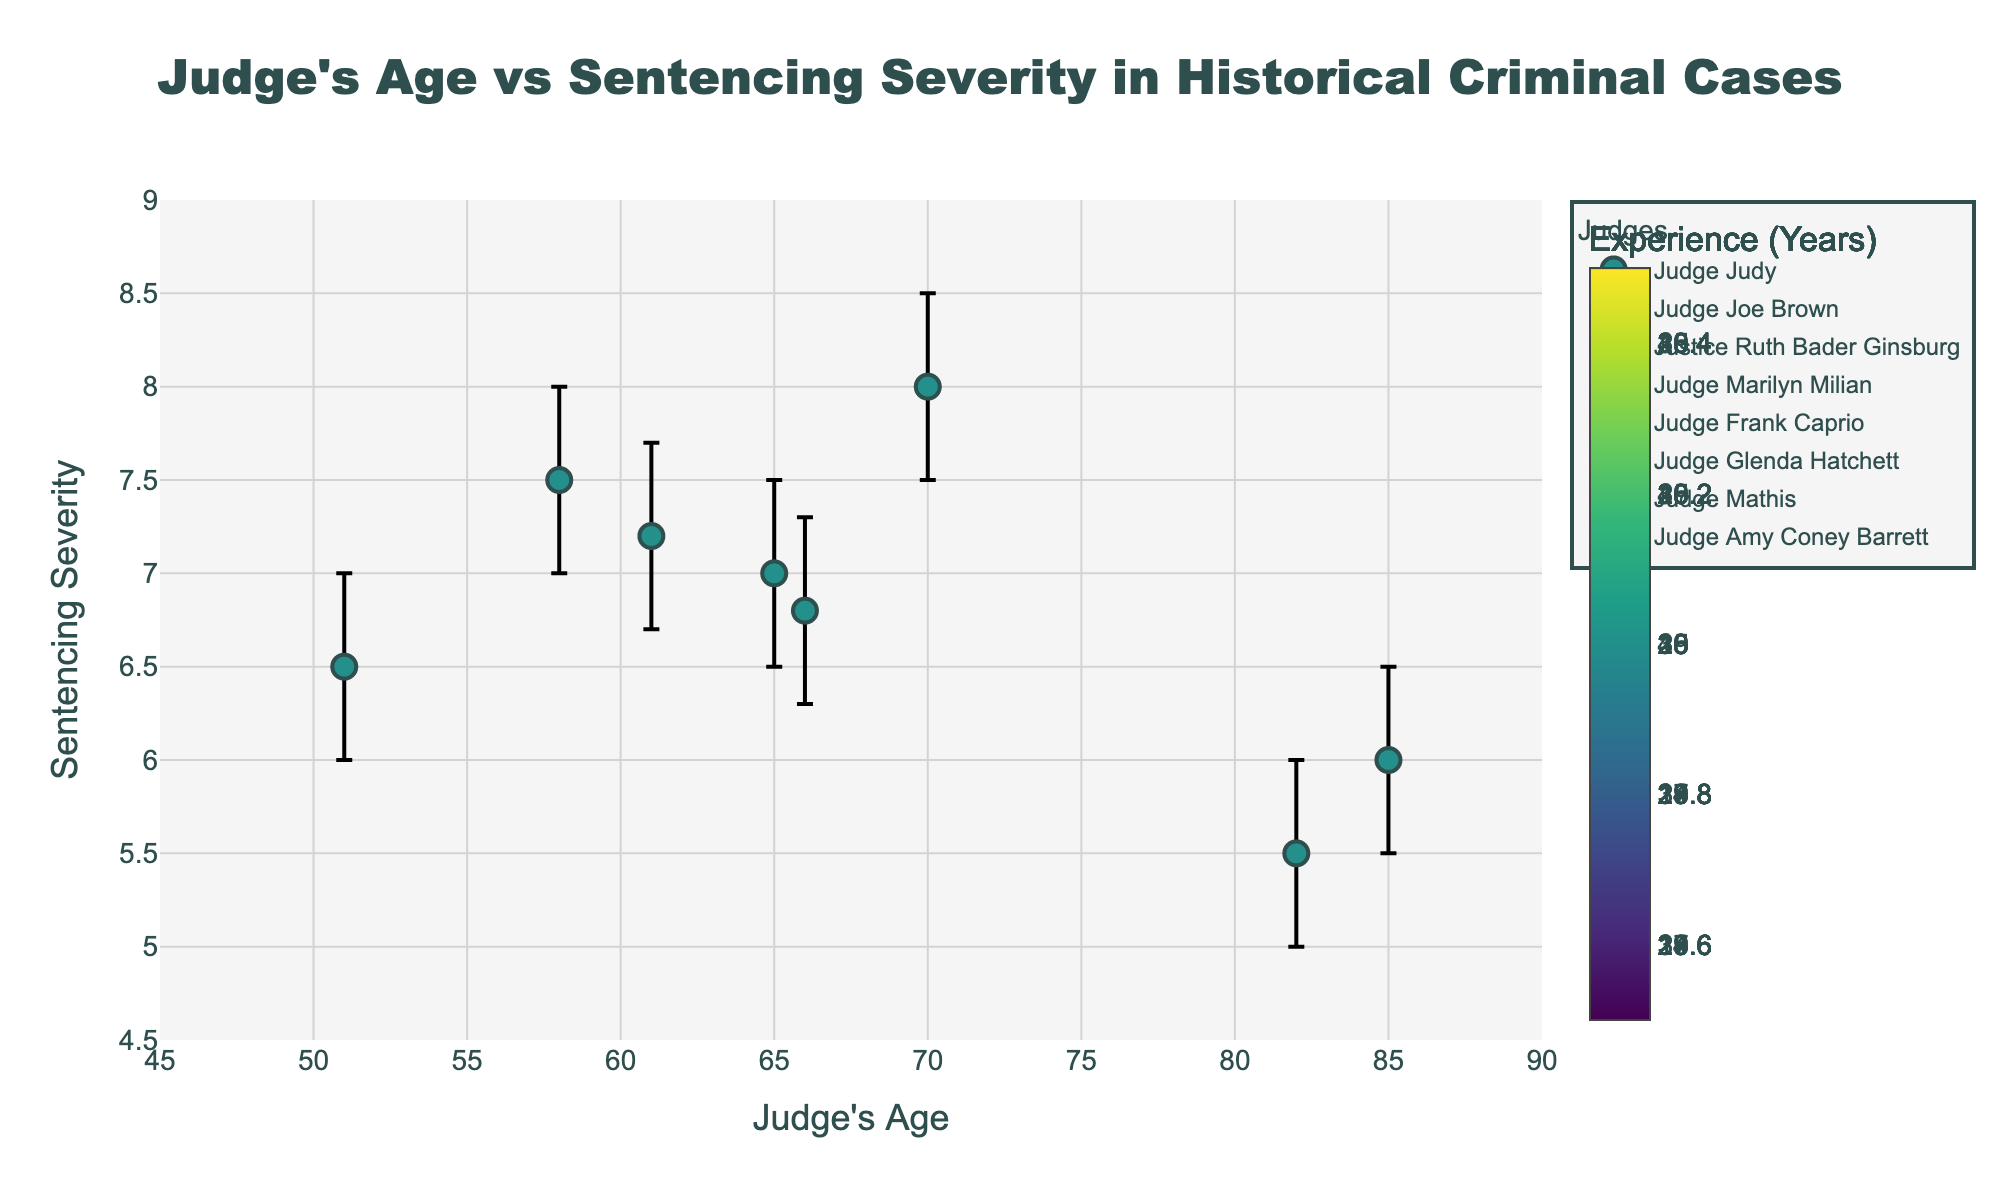What is the title of the plot? The title of the plot is usually located at the top center of the figure.
Answer: Judge's Age vs Sentencing Severity in Historical Criminal Cases Which judge has the highest sentencing severity score, and what is that score? By observing the y-axis and the data points, Judge Joe Brown has the highest sentencing severity score at 8.
Answer: Judge Joe Brown, 8 What is the age range of the judges represented in the plot? The x-axis represents the ages of the judges. The observed range of ages spans from the youngest judge, Amy Coney Barrett at 51, to the oldest, Justice Ruth Bader Ginsburg at 85.
Answer: 51-85 years Which judge has the lowest experience in years, and how many years is it? The color scale represents the experience in years. By comparing the color intensity or referring to the legend, Judge Amy Coney Barrett has the lowest experience at 15 years.
Answer: Judge Amy Coney Barrett, 15 years Do older judges tend to give more severe sentences? Observing the scatter plot, there doesn't appear to be a clear trend between age and sentencing severity. Some older judges, like Justice Ruth Bader Ginsburg, give less severe sentences, while others, like Judge Joe Brown, give more severe sentences. Similarly, younger judges also vary in their sentencing severity.
Answer: No clear trend Which judge has the widest confidence interval for sentencing severity? The widest confidence interval can be identified by looking at the length of the error bars. Judge Judy has an interval from 6.5 to 7.5, but Judge Marilyn Milian has a slightly longer interval from 7 to 8 spanning 1 unit. Using this information, we can identify the interval.
Answer: Judge Marilyn Milian Comparing Judge Judy and Judge Mathis, who has a more uncertain sentencing severity, and why? Uncertainty can be judged by the length of their error bars. Judge Judy’s interval is from 6.5 to 7.5 (1 unit wide), while Judge Mathis has an interval from 6.7 to 7.7 (also 1 unit wide), indicating similar uncertainty. Checking the deviation more precisely might highlight minor differences.
Answer: They have similar uncertainty Which judge has the highest experience, and what is their sentencing severity? Referring to the colors representing experience in years, the most experienced judge is Justice Ruth Bader Ginsburg with 40 years of experience, with a corresponding sentencing severity of 6.
Answer: Justice Ruth Bader Ginsburg, 6 How does the confidence interval of Judge Glenda Hatchett compare to Judge Frank Caprio? Judge Glenda Hatchett's confidence interval ranges from 6.3 to 7.3, a span of 1. Judge Frank Caprio's interval ranges from 5 to 6, also a span of 1. Both judges have confidence intervals of the same length.
Answer: They have the same length interval 